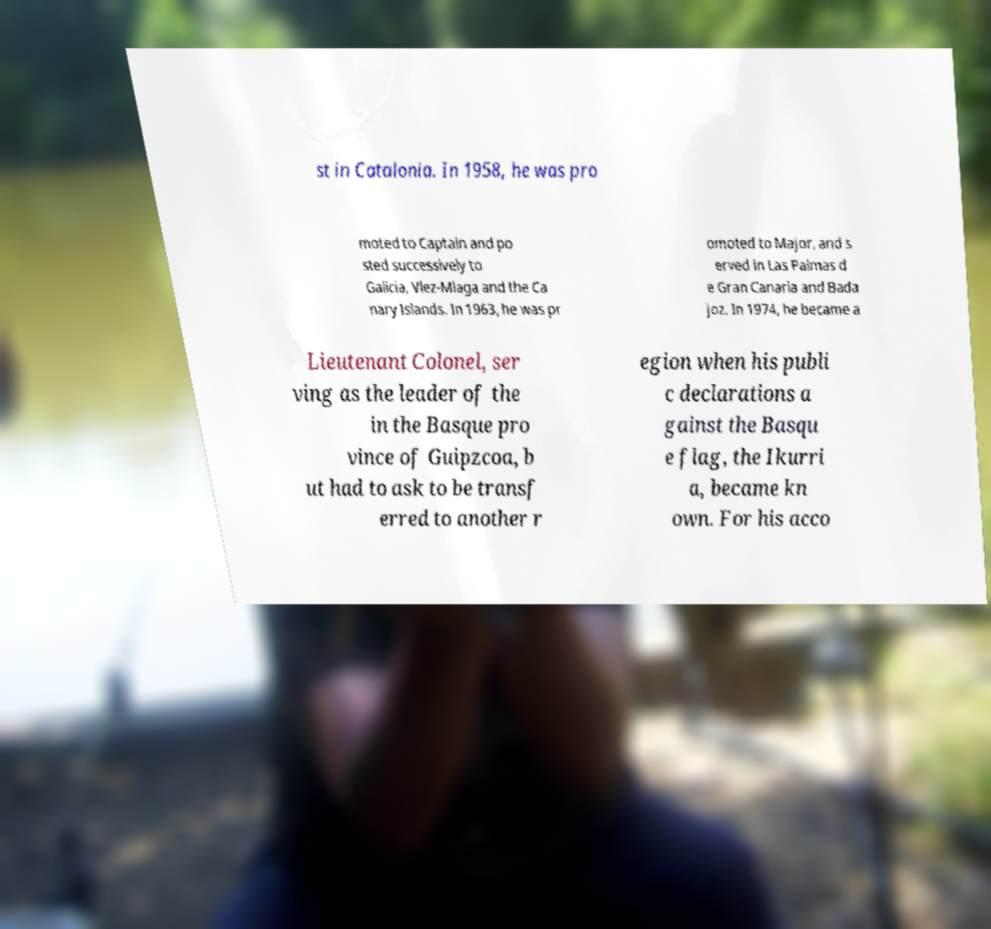Could you assist in decoding the text presented in this image and type it out clearly? st in Catalonia. In 1958, he was pro moted to Captain and po sted successively to Galicia, Vlez-Mlaga and the Ca nary Islands. In 1963, he was pr omoted to Major, and s erved in Las Palmas d e Gran Canaria and Bada joz. In 1974, he became a Lieutenant Colonel, ser ving as the leader of the in the Basque pro vince of Guipzcoa, b ut had to ask to be transf erred to another r egion when his publi c declarations a gainst the Basqu e flag, the Ikurri a, became kn own. For his acco 